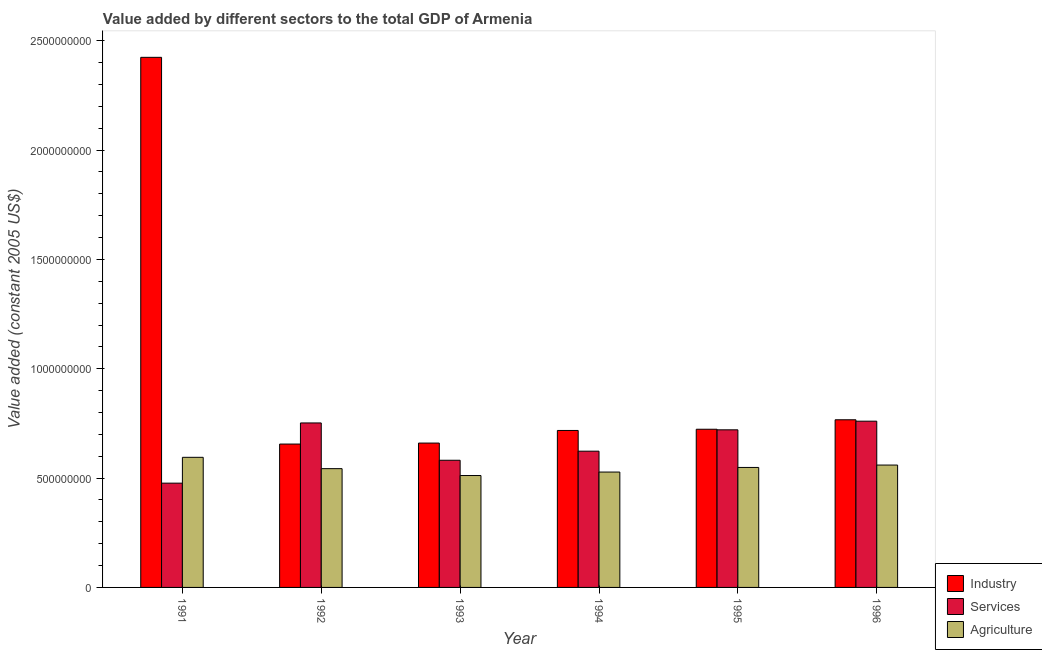How many groups of bars are there?
Keep it short and to the point. 6. Are the number of bars per tick equal to the number of legend labels?
Offer a terse response. Yes. What is the value added by agricultural sector in 1995?
Provide a short and direct response. 5.49e+08. Across all years, what is the maximum value added by services?
Make the answer very short. 7.60e+08. Across all years, what is the minimum value added by agricultural sector?
Offer a terse response. 5.12e+08. In which year was the value added by agricultural sector maximum?
Give a very brief answer. 1991. In which year was the value added by agricultural sector minimum?
Provide a short and direct response. 1993. What is the total value added by services in the graph?
Ensure brevity in your answer.  3.91e+09. What is the difference between the value added by industrial sector in 1995 and that in 1996?
Give a very brief answer. -4.33e+07. What is the difference between the value added by agricultural sector in 1996 and the value added by industrial sector in 1995?
Provide a short and direct response. 1.09e+07. What is the average value added by industrial sector per year?
Make the answer very short. 9.91e+08. In the year 1993, what is the difference between the value added by industrial sector and value added by services?
Your answer should be very brief. 0. In how many years, is the value added by agricultural sector greater than 600000000 US$?
Provide a short and direct response. 0. What is the ratio of the value added by services in 1993 to that in 1995?
Give a very brief answer. 0.81. Is the value added by industrial sector in 1991 less than that in 1996?
Your answer should be compact. No. Is the difference between the value added by services in 1991 and 1996 greater than the difference between the value added by agricultural sector in 1991 and 1996?
Keep it short and to the point. No. What is the difference between the highest and the second highest value added by agricultural sector?
Make the answer very short. 3.54e+07. What is the difference between the highest and the lowest value added by industrial sector?
Keep it short and to the point. 1.77e+09. In how many years, is the value added by industrial sector greater than the average value added by industrial sector taken over all years?
Keep it short and to the point. 1. Is the sum of the value added by agricultural sector in 1991 and 1992 greater than the maximum value added by services across all years?
Make the answer very short. Yes. What does the 2nd bar from the left in 1993 represents?
Your answer should be compact. Services. What does the 1st bar from the right in 1993 represents?
Provide a short and direct response. Agriculture. Are all the bars in the graph horizontal?
Make the answer very short. No. Does the graph contain any zero values?
Give a very brief answer. No. Does the graph contain grids?
Keep it short and to the point. No. How many legend labels are there?
Provide a succinct answer. 3. How are the legend labels stacked?
Give a very brief answer. Vertical. What is the title of the graph?
Give a very brief answer. Value added by different sectors to the total GDP of Armenia. Does "Agriculture" appear as one of the legend labels in the graph?
Provide a succinct answer. Yes. What is the label or title of the Y-axis?
Make the answer very short. Value added (constant 2005 US$). What is the Value added (constant 2005 US$) in Industry in 1991?
Your answer should be very brief. 2.42e+09. What is the Value added (constant 2005 US$) in Services in 1991?
Give a very brief answer. 4.77e+08. What is the Value added (constant 2005 US$) of Agriculture in 1991?
Your response must be concise. 5.95e+08. What is the Value added (constant 2005 US$) of Industry in 1992?
Give a very brief answer. 6.56e+08. What is the Value added (constant 2005 US$) of Services in 1992?
Make the answer very short. 7.52e+08. What is the Value added (constant 2005 US$) of Agriculture in 1992?
Offer a terse response. 5.43e+08. What is the Value added (constant 2005 US$) in Industry in 1993?
Keep it short and to the point. 6.60e+08. What is the Value added (constant 2005 US$) in Services in 1993?
Provide a succinct answer. 5.82e+08. What is the Value added (constant 2005 US$) in Agriculture in 1993?
Ensure brevity in your answer.  5.12e+08. What is the Value added (constant 2005 US$) in Industry in 1994?
Offer a very short reply. 7.18e+08. What is the Value added (constant 2005 US$) in Services in 1994?
Make the answer very short. 6.23e+08. What is the Value added (constant 2005 US$) in Agriculture in 1994?
Offer a very short reply. 5.28e+08. What is the Value added (constant 2005 US$) of Industry in 1995?
Keep it short and to the point. 7.23e+08. What is the Value added (constant 2005 US$) of Services in 1995?
Provide a succinct answer. 7.21e+08. What is the Value added (constant 2005 US$) of Agriculture in 1995?
Offer a very short reply. 5.49e+08. What is the Value added (constant 2005 US$) of Industry in 1996?
Make the answer very short. 7.67e+08. What is the Value added (constant 2005 US$) of Services in 1996?
Offer a very short reply. 7.60e+08. What is the Value added (constant 2005 US$) of Agriculture in 1996?
Your answer should be compact. 5.60e+08. Across all years, what is the maximum Value added (constant 2005 US$) in Industry?
Your answer should be compact. 2.42e+09. Across all years, what is the maximum Value added (constant 2005 US$) in Services?
Offer a very short reply. 7.60e+08. Across all years, what is the maximum Value added (constant 2005 US$) of Agriculture?
Offer a terse response. 5.95e+08. Across all years, what is the minimum Value added (constant 2005 US$) of Industry?
Your response must be concise. 6.56e+08. Across all years, what is the minimum Value added (constant 2005 US$) in Services?
Give a very brief answer. 4.77e+08. Across all years, what is the minimum Value added (constant 2005 US$) of Agriculture?
Your answer should be compact. 5.12e+08. What is the total Value added (constant 2005 US$) of Industry in the graph?
Offer a terse response. 5.95e+09. What is the total Value added (constant 2005 US$) of Services in the graph?
Provide a short and direct response. 3.91e+09. What is the total Value added (constant 2005 US$) of Agriculture in the graph?
Give a very brief answer. 3.29e+09. What is the difference between the Value added (constant 2005 US$) of Industry in 1991 and that in 1992?
Make the answer very short. 1.77e+09. What is the difference between the Value added (constant 2005 US$) of Services in 1991 and that in 1992?
Keep it short and to the point. -2.75e+08. What is the difference between the Value added (constant 2005 US$) of Agriculture in 1991 and that in 1992?
Offer a terse response. 5.18e+07. What is the difference between the Value added (constant 2005 US$) in Industry in 1991 and that in 1993?
Keep it short and to the point. 1.76e+09. What is the difference between the Value added (constant 2005 US$) of Services in 1991 and that in 1993?
Keep it short and to the point. -1.05e+08. What is the difference between the Value added (constant 2005 US$) of Agriculture in 1991 and that in 1993?
Ensure brevity in your answer.  8.33e+07. What is the difference between the Value added (constant 2005 US$) of Industry in 1991 and that in 1994?
Provide a short and direct response. 1.71e+09. What is the difference between the Value added (constant 2005 US$) of Services in 1991 and that in 1994?
Your answer should be compact. -1.46e+08. What is the difference between the Value added (constant 2005 US$) of Agriculture in 1991 and that in 1994?
Your response must be concise. 6.74e+07. What is the difference between the Value added (constant 2005 US$) of Industry in 1991 and that in 1995?
Provide a succinct answer. 1.70e+09. What is the difference between the Value added (constant 2005 US$) of Services in 1991 and that in 1995?
Offer a terse response. -2.44e+08. What is the difference between the Value added (constant 2005 US$) of Agriculture in 1991 and that in 1995?
Provide a short and direct response. 4.63e+07. What is the difference between the Value added (constant 2005 US$) of Industry in 1991 and that in 1996?
Ensure brevity in your answer.  1.66e+09. What is the difference between the Value added (constant 2005 US$) in Services in 1991 and that in 1996?
Provide a succinct answer. -2.83e+08. What is the difference between the Value added (constant 2005 US$) in Agriculture in 1991 and that in 1996?
Give a very brief answer. 3.54e+07. What is the difference between the Value added (constant 2005 US$) in Industry in 1992 and that in 1993?
Your response must be concise. -4.49e+06. What is the difference between the Value added (constant 2005 US$) of Services in 1992 and that in 1993?
Your answer should be very brief. 1.71e+08. What is the difference between the Value added (constant 2005 US$) of Agriculture in 1992 and that in 1993?
Provide a short and direct response. 3.15e+07. What is the difference between the Value added (constant 2005 US$) of Industry in 1992 and that in 1994?
Provide a succinct answer. -6.21e+07. What is the difference between the Value added (constant 2005 US$) of Services in 1992 and that in 1994?
Give a very brief answer. 1.29e+08. What is the difference between the Value added (constant 2005 US$) of Agriculture in 1992 and that in 1994?
Provide a short and direct response. 1.56e+07. What is the difference between the Value added (constant 2005 US$) in Industry in 1992 and that in 1995?
Give a very brief answer. -6.77e+07. What is the difference between the Value added (constant 2005 US$) of Services in 1992 and that in 1995?
Make the answer very short. 3.14e+07. What is the difference between the Value added (constant 2005 US$) in Agriculture in 1992 and that in 1995?
Make the answer very short. -5.46e+06. What is the difference between the Value added (constant 2005 US$) in Industry in 1992 and that in 1996?
Keep it short and to the point. -1.11e+08. What is the difference between the Value added (constant 2005 US$) in Services in 1992 and that in 1996?
Your answer should be compact. -8.04e+06. What is the difference between the Value added (constant 2005 US$) in Agriculture in 1992 and that in 1996?
Provide a short and direct response. -1.64e+07. What is the difference between the Value added (constant 2005 US$) of Industry in 1993 and that in 1994?
Make the answer very short. -5.76e+07. What is the difference between the Value added (constant 2005 US$) of Services in 1993 and that in 1994?
Your response must be concise. -4.16e+07. What is the difference between the Value added (constant 2005 US$) of Agriculture in 1993 and that in 1994?
Your answer should be compact. -1.59e+07. What is the difference between the Value added (constant 2005 US$) of Industry in 1993 and that in 1995?
Offer a very short reply. -6.32e+07. What is the difference between the Value added (constant 2005 US$) in Services in 1993 and that in 1995?
Keep it short and to the point. -1.39e+08. What is the difference between the Value added (constant 2005 US$) of Agriculture in 1993 and that in 1995?
Your response must be concise. -3.70e+07. What is the difference between the Value added (constant 2005 US$) of Industry in 1993 and that in 1996?
Keep it short and to the point. -1.07e+08. What is the difference between the Value added (constant 2005 US$) in Services in 1993 and that in 1996?
Provide a short and direct response. -1.79e+08. What is the difference between the Value added (constant 2005 US$) of Agriculture in 1993 and that in 1996?
Provide a succinct answer. -4.79e+07. What is the difference between the Value added (constant 2005 US$) of Industry in 1994 and that in 1995?
Your response must be concise. -5.61e+06. What is the difference between the Value added (constant 2005 US$) in Services in 1994 and that in 1995?
Make the answer very short. -9.77e+07. What is the difference between the Value added (constant 2005 US$) of Agriculture in 1994 and that in 1995?
Provide a succinct answer. -2.11e+07. What is the difference between the Value added (constant 2005 US$) in Industry in 1994 and that in 1996?
Keep it short and to the point. -4.89e+07. What is the difference between the Value added (constant 2005 US$) in Services in 1994 and that in 1996?
Keep it short and to the point. -1.37e+08. What is the difference between the Value added (constant 2005 US$) in Agriculture in 1994 and that in 1996?
Offer a very short reply. -3.20e+07. What is the difference between the Value added (constant 2005 US$) of Industry in 1995 and that in 1996?
Make the answer very short. -4.33e+07. What is the difference between the Value added (constant 2005 US$) of Services in 1995 and that in 1996?
Provide a short and direct response. -3.95e+07. What is the difference between the Value added (constant 2005 US$) in Agriculture in 1995 and that in 1996?
Offer a terse response. -1.09e+07. What is the difference between the Value added (constant 2005 US$) in Industry in 1991 and the Value added (constant 2005 US$) in Services in 1992?
Provide a succinct answer. 1.67e+09. What is the difference between the Value added (constant 2005 US$) in Industry in 1991 and the Value added (constant 2005 US$) in Agriculture in 1992?
Provide a succinct answer. 1.88e+09. What is the difference between the Value added (constant 2005 US$) in Services in 1991 and the Value added (constant 2005 US$) in Agriculture in 1992?
Give a very brief answer. -6.63e+07. What is the difference between the Value added (constant 2005 US$) of Industry in 1991 and the Value added (constant 2005 US$) of Services in 1993?
Your answer should be very brief. 1.84e+09. What is the difference between the Value added (constant 2005 US$) of Industry in 1991 and the Value added (constant 2005 US$) of Agriculture in 1993?
Your response must be concise. 1.91e+09. What is the difference between the Value added (constant 2005 US$) of Services in 1991 and the Value added (constant 2005 US$) of Agriculture in 1993?
Offer a terse response. -3.48e+07. What is the difference between the Value added (constant 2005 US$) of Industry in 1991 and the Value added (constant 2005 US$) of Services in 1994?
Keep it short and to the point. 1.80e+09. What is the difference between the Value added (constant 2005 US$) of Industry in 1991 and the Value added (constant 2005 US$) of Agriculture in 1994?
Make the answer very short. 1.90e+09. What is the difference between the Value added (constant 2005 US$) in Services in 1991 and the Value added (constant 2005 US$) in Agriculture in 1994?
Your answer should be compact. -5.07e+07. What is the difference between the Value added (constant 2005 US$) of Industry in 1991 and the Value added (constant 2005 US$) of Services in 1995?
Make the answer very short. 1.70e+09. What is the difference between the Value added (constant 2005 US$) in Industry in 1991 and the Value added (constant 2005 US$) in Agriculture in 1995?
Your answer should be very brief. 1.88e+09. What is the difference between the Value added (constant 2005 US$) of Services in 1991 and the Value added (constant 2005 US$) of Agriculture in 1995?
Offer a very short reply. -7.18e+07. What is the difference between the Value added (constant 2005 US$) in Industry in 1991 and the Value added (constant 2005 US$) in Services in 1996?
Your answer should be compact. 1.66e+09. What is the difference between the Value added (constant 2005 US$) of Industry in 1991 and the Value added (constant 2005 US$) of Agriculture in 1996?
Your response must be concise. 1.86e+09. What is the difference between the Value added (constant 2005 US$) in Services in 1991 and the Value added (constant 2005 US$) in Agriculture in 1996?
Your answer should be compact. -8.27e+07. What is the difference between the Value added (constant 2005 US$) in Industry in 1992 and the Value added (constant 2005 US$) in Services in 1993?
Keep it short and to the point. 7.41e+07. What is the difference between the Value added (constant 2005 US$) in Industry in 1992 and the Value added (constant 2005 US$) in Agriculture in 1993?
Keep it short and to the point. 1.44e+08. What is the difference between the Value added (constant 2005 US$) in Services in 1992 and the Value added (constant 2005 US$) in Agriculture in 1993?
Make the answer very short. 2.40e+08. What is the difference between the Value added (constant 2005 US$) of Industry in 1992 and the Value added (constant 2005 US$) of Services in 1994?
Offer a very short reply. 3.26e+07. What is the difference between the Value added (constant 2005 US$) of Industry in 1992 and the Value added (constant 2005 US$) of Agriculture in 1994?
Make the answer very short. 1.28e+08. What is the difference between the Value added (constant 2005 US$) of Services in 1992 and the Value added (constant 2005 US$) of Agriculture in 1994?
Your response must be concise. 2.25e+08. What is the difference between the Value added (constant 2005 US$) of Industry in 1992 and the Value added (constant 2005 US$) of Services in 1995?
Make the answer very short. -6.51e+07. What is the difference between the Value added (constant 2005 US$) of Industry in 1992 and the Value added (constant 2005 US$) of Agriculture in 1995?
Keep it short and to the point. 1.07e+08. What is the difference between the Value added (constant 2005 US$) of Services in 1992 and the Value added (constant 2005 US$) of Agriculture in 1995?
Keep it short and to the point. 2.04e+08. What is the difference between the Value added (constant 2005 US$) in Industry in 1992 and the Value added (constant 2005 US$) in Services in 1996?
Your answer should be compact. -1.05e+08. What is the difference between the Value added (constant 2005 US$) of Industry in 1992 and the Value added (constant 2005 US$) of Agriculture in 1996?
Offer a very short reply. 9.61e+07. What is the difference between the Value added (constant 2005 US$) of Services in 1992 and the Value added (constant 2005 US$) of Agriculture in 1996?
Provide a succinct answer. 1.93e+08. What is the difference between the Value added (constant 2005 US$) of Industry in 1993 and the Value added (constant 2005 US$) of Services in 1994?
Give a very brief answer. 3.71e+07. What is the difference between the Value added (constant 2005 US$) in Industry in 1993 and the Value added (constant 2005 US$) in Agriculture in 1994?
Offer a very short reply. 1.33e+08. What is the difference between the Value added (constant 2005 US$) of Services in 1993 and the Value added (constant 2005 US$) of Agriculture in 1994?
Your response must be concise. 5.40e+07. What is the difference between the Value added (constant 2005 US$) of Industry in 1993 and the Value added (constant 2005 US$) of Services in 1995?
Ensure brevity in your answer.  -6.06e+07. What is the difference between the Value added (constant 2005 US$) of Industry in 1993 and the Value added (constant 2005 US$) of Agriculture in 1995?
Your answer should be compact. 1.11e+08. What is the difference between the Value added (constant 2005 US$) in Services in 1993 and the Value added (constant 2005 US$) in Agriculture in 1995?
Your answer should be very brief. 3.29e+07. What is the difference between the Value added (constant 2005 US$) in Industry in 1993 and the Value added (constant 2005 US$) in Services in 1996?
Your response must be concise. -1.00e+08. What is the difference between the Value added (constant 2005 US$) of Industry in 1993 and the Value added (constant 2005 US$) of Agriculture in 1996?
Offer a terse response. 1.01e+08. What is the difference between the Value added (constant 2005 US$) of Services in 1993 and the Value added (constant 2005 US$) of Agriculture in 1996?
Give a very brief answer. 2.19e+07. What is the difference between the Value added (constant 2005 US$) of Industry in 1994 and the Value added (constant 2005 US$) of Services in 1995?
Keep it short and to the point. -2.93e+06. What is the difference between the Value added (constant 2005 US$) of Industry in 1994 and the Value added (constant 2005 US$) of Agriculture in 1995?
Offer a very short reply. 1.69e+08. What is the difference between the Value added (constant 2005 US$) of Services in 1994 and the Value added (constant 2005 US$) of Agriculture in 1995?
Offer a terse response. 7.44e+07. What is the difference between the Value added (constant 2005 US$) of Industry in 1994 and the Value added (constant 2005 US$) of Services in 1996?
Give a very brief answer. -4.24e+07. What is the difference between the Value added (constant 2005 US$) in Industry in 1994 and the Value added (constant 2005 US$) in Agriculture in 1996?
Make the answer very short. 1.58e+08. What is the difference between the Value added (constant 2005 US$) of Services in 1994 and the Value added (constant 2005 US$) of Agriculture in 1996?
Your response must be concise. 6.35e+07. What is the difference between the Value added (constant 2005 US$) in Industry in 1995 and the Value added (constant 2005 US$) in Services in 1996?
Your response must be concise. -3.68e+07. What is the difference between the Value added (constant 2005 US$) in Industry in 1995 and the Value added (constant 2005 US$) in Agriculture in 1996?
Give a very brief answer. 1.64e+08. What is the difference between the Value added (constant 2005 US$) in Services in 1995 and the Value added (constant 2005 US$) in Agriculture in 1996?
Offer a very short reply. 1.61e+08. What is the average Value added (constant 2005 US$) of Industry per year?
Your answer should be very brief. 9.91e+08. What is the average Value added (constant 2005 US$) in Services per year?
Offer a very short reply. 6.52e+08. What is the average Value added (constant 2005 US$) in Agriculture per year?
Ensure brevity in your answer.  5.48e+08. In the year 1991, what is the difference between the Value added (constant 2005 US$) of Industry and Value added (constant 2005 US$) of Services?
Provide a short and direct response. 1.95e+09. In the year 1991, what is the difference between the Value added (constant 2005 US$) in Industry and Value added (constant 2005 US$) in Agriculture?
Ensure brevity in your answer.  1.83e+09. In the year 1991, what is the difference between the Value added (constant 2005 US$) of Services and Value added (constant 2005 US$) of Agriculture?
Your answer should be very brief. -1.18e+08. In the year 1992, what is the difference between the Value added (constant 2005 US$) of Industry and Value added (constant 2005 US$) of Services?
Offer a terse response. -9.65e+07. In the year 1992, what is the difference between the Value added (constant 2005 US$) of Industry and Value added (constant 2005 US$) of Agriculture?
Offer a very short reply. 1.12e+08. In the year 1992, what is the difference between the Value added (constant 2005 US$) of Services and Value added (constant 2005 US$) of Agriculture?
Your answer should be compact. 2.09e+08. In the year 1993, what is the difference between the Value added (constant 2005 US$) in Industry and Value added (constant 2005 US$) in Services?
Provide a short and direct response. 7.86e+07. In the year 1993, what is the difference between the Value added (constant 2005 US$) of Industry and Value added (constant 2005 US$) of Agriculture?
Your response must be concise. 1.48e+08. In the year 1993, what is the difference between the Value added (constant 2005 US$) of Services and Value added (constant 2005 US$) of Agriculture?
Make the answer very short. 6.98e+07. In the year 1994, what is the difference between the Value added (constant 2005 US$) in Industry and Value added (constant 2005 US$) in Services?
Provide a succinct answer. 9.47e+07. In the year 1994, what is the difference between the Value added (constant 2005 US$) in Industry and Value added (constant 2005 US$) in Agriculture?
Your answer should be compact. 1.90e+08. In the year 1994, what is the difference between the Value added (constant 2005 US$) of Services and Value added (constant 2005 US$) of Agriculture?
Provide a short and direct response. 9.55e+07. In the year 1995, what is the difference between the Value added (constant 2005 US$) in Industry and Value added (constant 2005 US$) in Services?
Keep it short and to the point. 2.67e+06. In the year 1995, what is the difference between the Value added (constant 2005 US$) of Industry and Value added (constant 2005 US$) of Agriculture?
Your response must be concise. 1.75e+08. In the year 1995, what is the difference between the Value added (constant 2005 US$) of Services and Value added (constant 2005 US$) of Agriculture?
Offer a terse response. 1.72e+08. In the year 1996, what is the difference between the Value added (constant 2005 US$) in Industry and Value added (constant 2005 US$) in Services?
Provide a short and direct response. 6.44e+06. In the year 1996, what is the difference between the Value added (constant 2005 US$) of Industry and Value added (constant 2005 US$) of Agriculture?
Offer a terse response. 2.07e+08. In the year 1996, what is the difference between the Value added (constant 2005 US$) of Services and Value added (constant 2005 US$) of Agriculture?
Provide a succinct answer. 2.01e+08. What is the ratio of the Value added (constant 2005 US$) of Industry in 1991 to that in 1992?
Your answer should be compact. 3.7. What is the ratio of the Value added (constant 2005 US$) in Services in 1991 to that in 1992?
Provide a succinct answer. 0.63. What is the ratio of the Value added (constant 2005 US$) in Agriculture in 1991 to that in 1992?
Offer a terse response. 1.1. What is the ratio of the Value added (constant 2005 US$) in Industry in 1991 to that in 1993?
Provide a succinct answer. 3.67. What is the ratio of the Value added (constant 2005 US$) of Services in 1991 to that in 1993?
Your response must be concise. 0.82. What is the ratio of the Value added (constant 2005 US$) of Agriculture in 1991 to that in 1993?
Offer a terse response. 1.16. What is the ratio of the Value added (constant 2005 US$) of Industry in 1991 to that in 1994?
Your answer should be very brief. 3.38. What is the ratio of the Value added (constant 2005 US$) in Services in 1991 to that in 1994?
Your answer should be very brief. 0.77. What is the ratio of the Value added (constant 2005 US$) of Agriculture in 1991 to that in 1994?
Give a very brief answer. 1.13. What is the ratio of the Value added (constant 2005 US$) of Industry in 1991 to that in 1995?
Your answer should be very brief. 3.35. What is the ratio of the Value added (constant 2005 US$) in Services in 1991 to that in 1995?
Provide a succinct answer. 0.66. What is the ratio of the Value added (constant 2005 US$) in Agriculture in 1991 to that in 1995?
Your answer should be compact. 1.08. What is the ratio of the Value added (constant 2005 US$) of Industry in 1991 to that in 1996?
Ensure brevity in your answer.  3.16. What is the ratio of the Value added (constant 2005 US$) in Services in 1991 to that in 1996?
Keep it short and to the point. 0.63. What is the ratio of the Value added (constant 2005 US$) of Agriculture in 1991 to that in 1996?
Your answer should be very brief. 1.06. What is the ratio of the Value added (constant 2005 US$) in Services in 1992 to that in 1993?
Offer a very short reply. 1.29. What is the ratio of the Value added (constant 2005 US$) of Agriculture in 1992 to that in 1993?
Your response must be concise. 1.06. What is the ratio of the Value added (constant 2005 US$) in Industry in 1992 to that in 1994?
Provide a short and direct response. 0.91. What is the ratio of the Value added (constant 2005 US$) of Services in 1992 to that in 1994?
Your response must be concise. 1.21. What is the ratio of the Value added (constant 2005 US$) in Agriculture in 1992 to that in 1994?
Provide a succinct answer. 1.03. What is the ratio of the Value added (constant 2005 US$) of Industry in 1992 to that in 1995?
Your answer should be very brief. 0.91. What is the ratio of the Value added (constant 2005 US$) of Services in 1992 to that in 1995?
Your answer should be compact. 1.04. What is the ratio of the Value added (constant 2005 US$) in Agriculture in 1992 to that in 1995?
Your answer should be compact. 0.99. What is the ratio of the Value added (constant 2005 US$) in Industry in 1992 to that in 1996?
Your answer should be very brief. 0.86. What is the ratio of the Value added (constant 2005 US$) of Services in 1992 to that in 1996?
Your answer should be compact. 0.99. What is the ratio of the Value added (constant 2005 US$) in Agriculture in 1992 to that in 1996?
Ensure brevity in your answer.  0.97. What is the ratio of the Value added (constant 2005 US$) in Industry in 1993 to that in 1994?
Your answer should be compact. 0.92. What is the ratio of the Value added (constant 2005 US$) in Services in 1993 to that in 1994?
Offer a very short reply. 0.93. What is the ratio of the Value added (constant 2005 US$) in Agriculture in 1993 to that in 1994?
Your answer should be compact. 0.97. What is the ratio of the Value added (constant 2005 US$) of Industry in 1993 to that in 1995?
Offer a very short reply. 0.91. What is the ratio of the Value added (constant 2005 US$) of Services in 1993 to that in 1995?
Your response must be concise. 0.81. What is the ratio of the Value added (constant 2005 US$) in Agriculture in 1993 to that in 1995?
Make the answer very short. 0.93. What is the ratio of the Value added (constant 2005 US$) of Industry in 1993 to that in 1996?
Give a very brief answer. 0.86. What is the ratio of the Value added (constant 2005 US$) of Services in 1993 to that in 1996?
Provide a succinct answer. 0.76. What is the ratio of the Value added (constant 2005 US$) in Agriculture in 1993 to that in 1996?
Your response must be concise. 0.91. What is the ratio of the Value added (constant 2005 US$) of Industry in 1994 to that in 1995?
Make the answer very short. 0.99. What is the ratio of the Value added (constant 2005 US$) in Services in 1994 to that in 1995?
Make the answer very short. 0.86. What is the ratio of the Value added (constant 2005 US$) of Agriculture in 1994 to that in 1995?
Your answer should be very brief. 0.96. What is the ratio of the Value added (constant 2005 US$) in Industry in 1994 to that in 1996?
Ensure brevity in your answer.  0.94. What is the ratio of the Value added (constant 2005 US$) of Services in 1994 to that in 1996?
Provide a short and direct response. 0.82. What is the ratio of the Value added (constant 2005 US$) in Agriculture in 1994 to that in 1996?
Keep it short and to the point. 0.94. What is the ratio of the Value added (constant 2005 US$) of Industry in 1995 to that in 1996?
Make the answer very short. 0.94. What is the ratio of the Value added (constant 2005 US$) of Services in 1995 to that in 1996?
Offer a terse response. 0.95. What is the ratio of the Value added (constant 2005 US$) in Agriculture in 1995 to that in 1996?
Keep it short and to the point. 0.98. What is the difference between the highest and the second highest Value added (constant 2005 US$) of Industry?
Keep it short and to the point. 1.66e+09. What is the difference between the highest and the second highest Value added (constant 2005 US$) in Services?
Offer a very short reply. 8.04e+06. What is the difference between the highest and the second highest Value added (constant 2005 US$) in Agriculture?
Your answer should be very brief. 3.54e+07. What is the difference between the highest and the lowest Value added (constant 2005 US$) in Industry?
Your response must be concise. 1.77e+09. What is the difference between the highest and the lowest Value added (constant 2005 US$) of Services?
Offer a very short reply. 2.83e+08. What is the difference between the highest and the lowest Value added (constant 2005 US$) of Agriculture?
Give a very brief answer. 8.33e+07. 